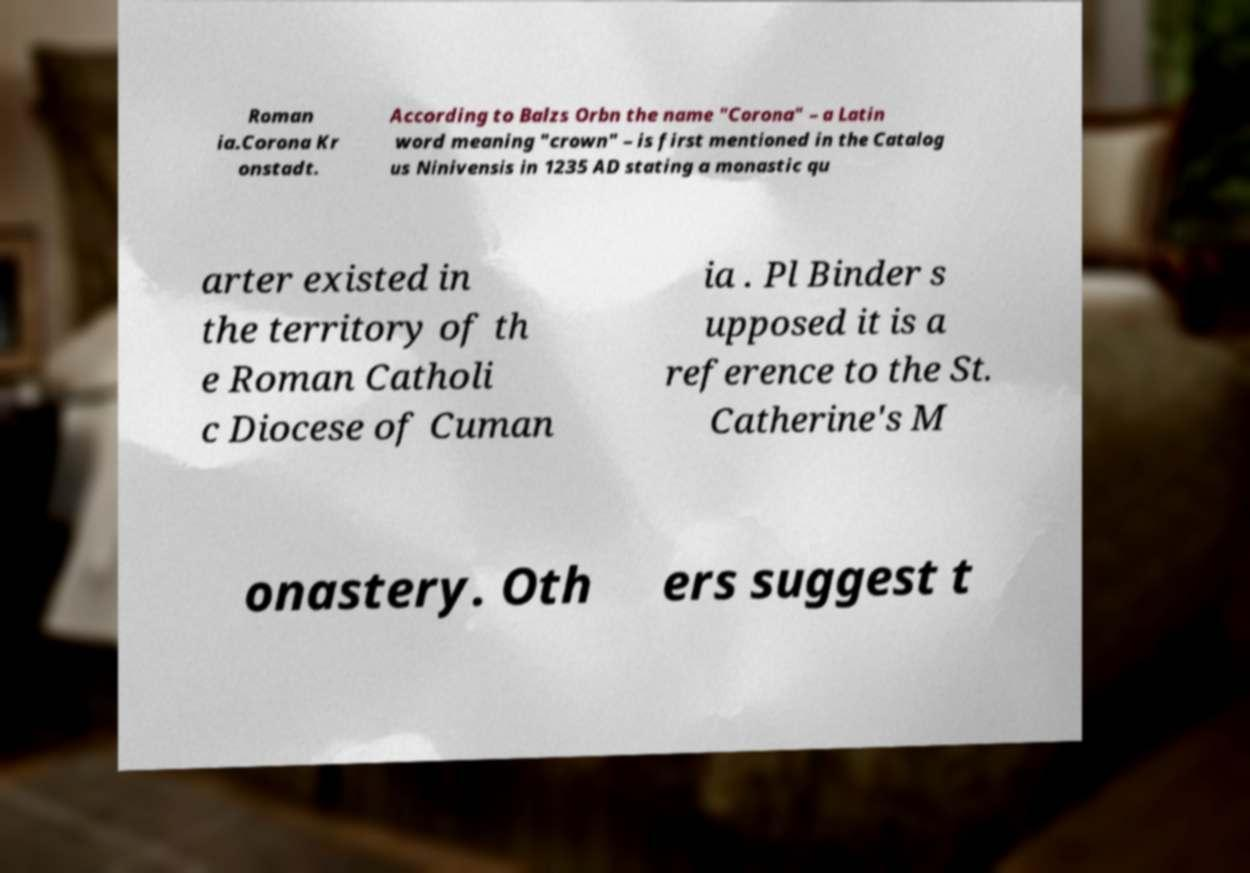Please identify and transcribe the text found in this image. Roman ia.Corona Kr onstadt. According to Balzs Orbn the name "Corona" – a Latin word meaning "crown" – is first mentioned in the Catalog us Ninivensis in 1235 AD stating a monastic qu arter existed in the territory of th e Roman Catholi c Diocese of Cuman ia . Pl Binder s upposed it is a reference to the St. Catherine's M onastery. Oth ers suggest t 